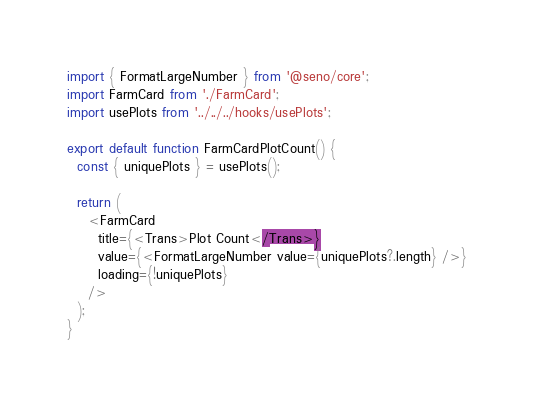<code> <loc_0><loc_0><loc_500><loc_500><_TypeScript_>import { FormatLargeNumber } from '@seno/core';
import FarmCard from './FarmCard';
import usePlots from '../../../hooks/usePlots';

export default function FarmCardPlotCount() {
  const { uniquePlots } = usePlots();

  return (
    <FarmCard
      title={<Trans>Plot Count</Trans>}
      value={<FormatLargeNumber value={uniquePlots?.length} />}
      loading={!uniquePlots}
    />
  );
}
</code> 